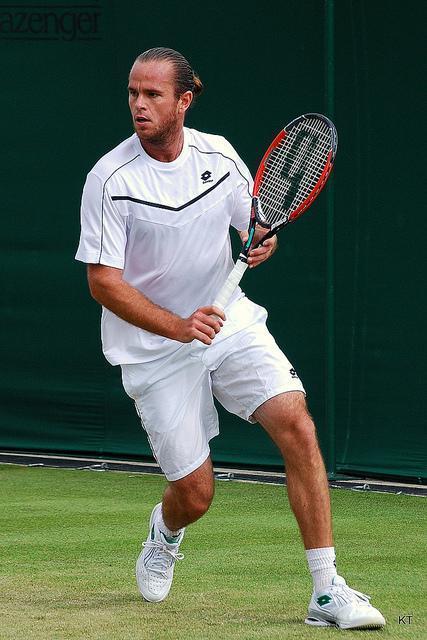How many boats are in the picture?
Give a very brief answer. 0. 